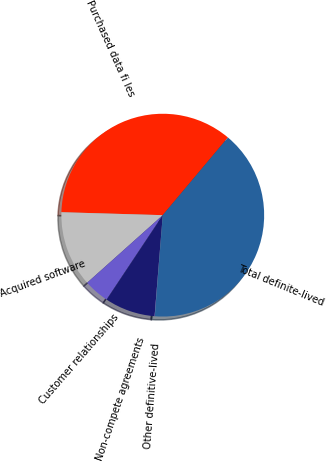<chart> <loc_0><loc_0><loc_500><loc_500><pie_chart><fcel>Purchased data fi les<fcel>Acquired software<fcel>Customer relationships<fcel>Non-compete agreements<fcel>Other definitive-lived<fcel>Total definite-lived<nl><fcel>35.66%<fcel>12.07%<fcel>4.05%<fcel>8.06%<fcel>0.04%<fcel>40.13%<nl></chart> 